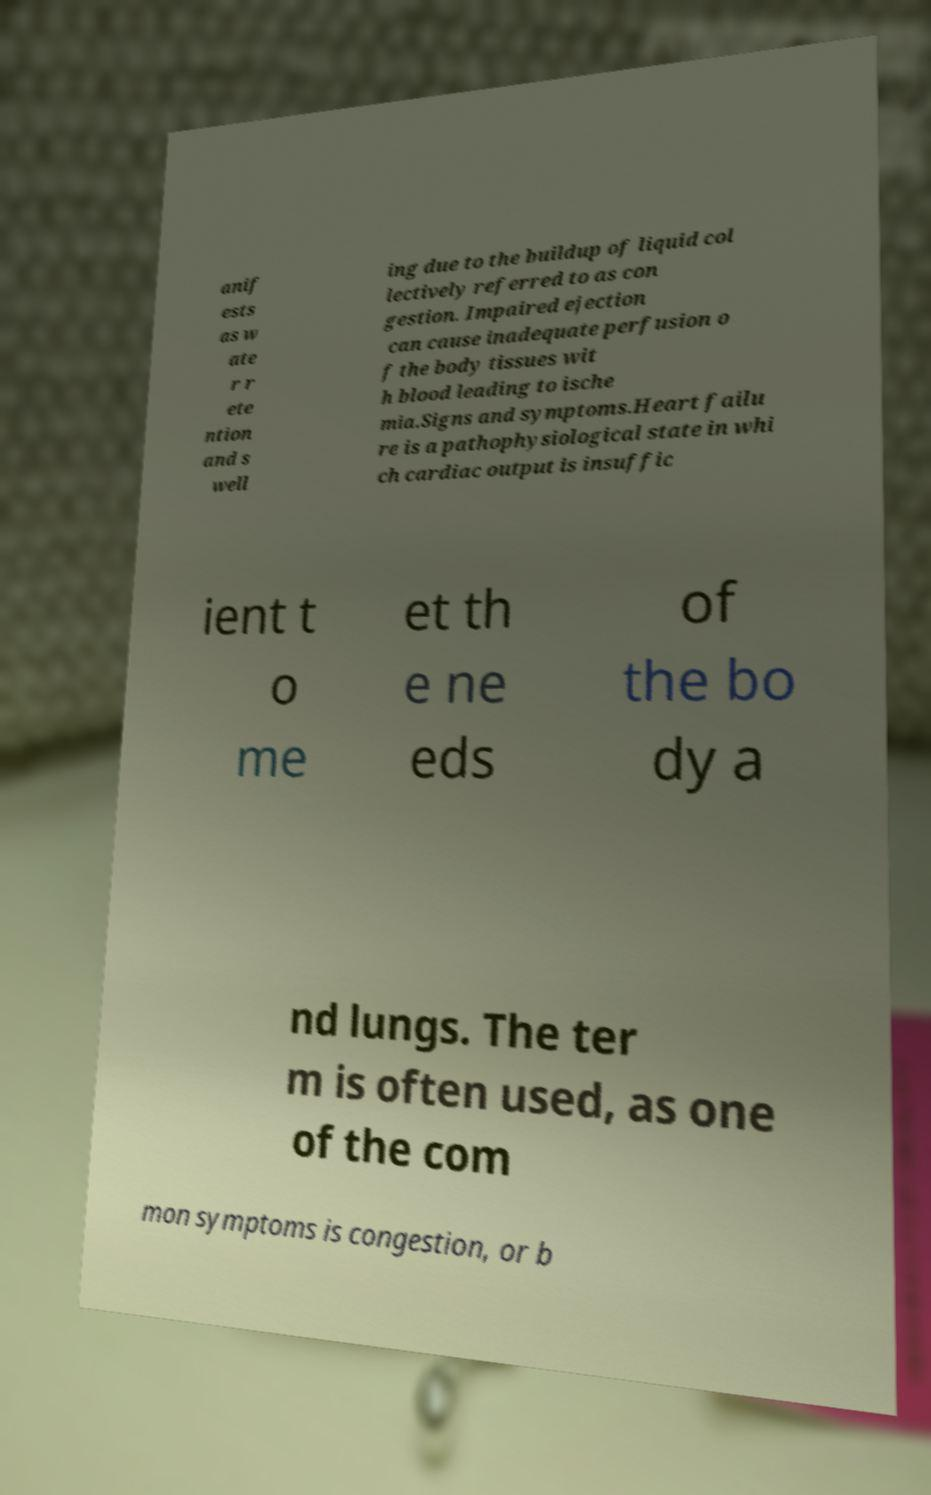For documentation purposes, I need the text within this image transcribed. Could you provide that? anif ests as w ate r r ete ntion and s well ing due to the buildup of liquid col lectively referred to as con gestion. Impaired ejection can cause inadequate perfusion o f the body tissues wit h blood leading to ische mia.Signs and symptoms.Heart failu re is a pathophysiological state in whi ch cardiac output is insuffic ient t o me et th e ne eds of the bo dy a nd lungs. The ter m is often used, as one of the com mon symptoms is congestion, or b 